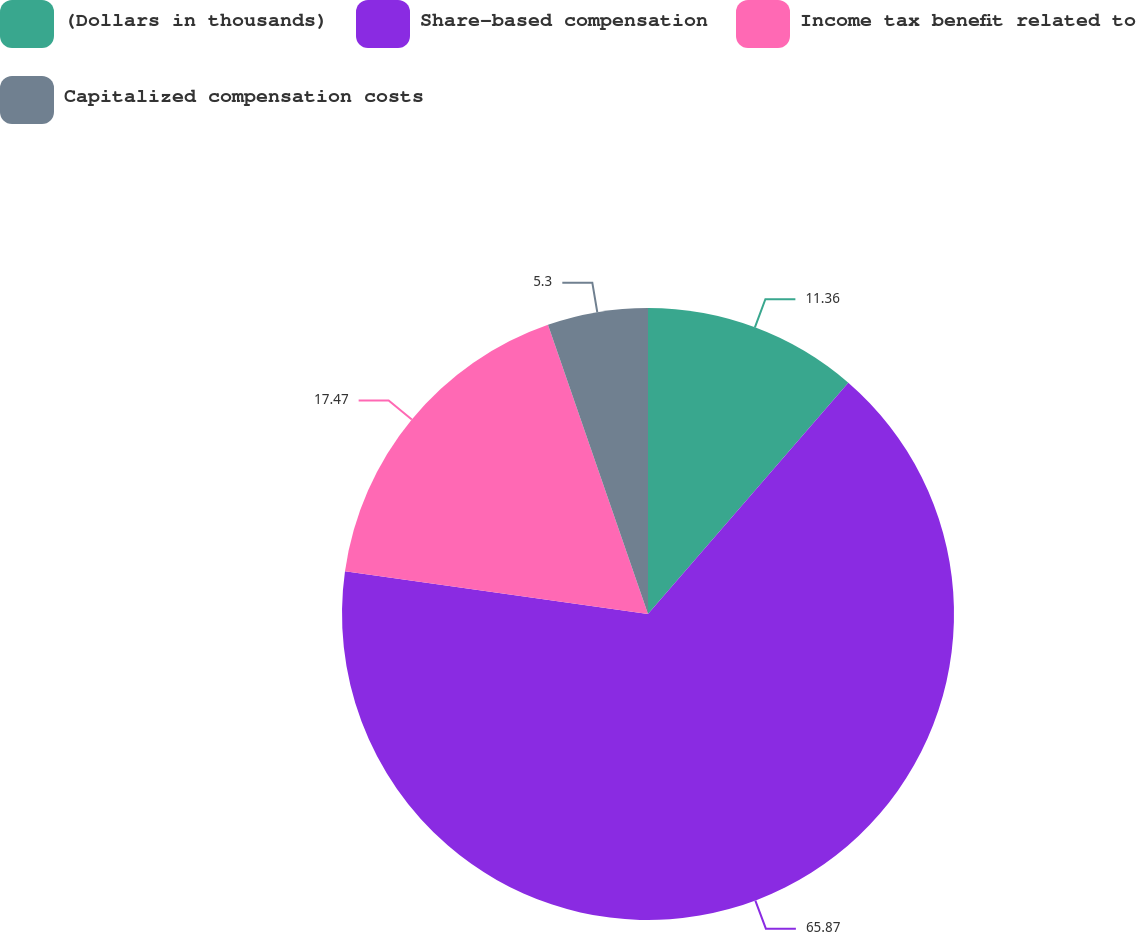Convert chart. <chart><loc_0><loc_0><loc_500><loc_500><pie_chart><fcel>(Dollars in thousands)<fcel>Share-based compensation<fcel>Income tax benefit related to<fcel>Capitalized compensation costs<nl><fcel>11.36%<fcel>65.87%<fcel>17.47%<fcel>5.3%<nl></chart> 